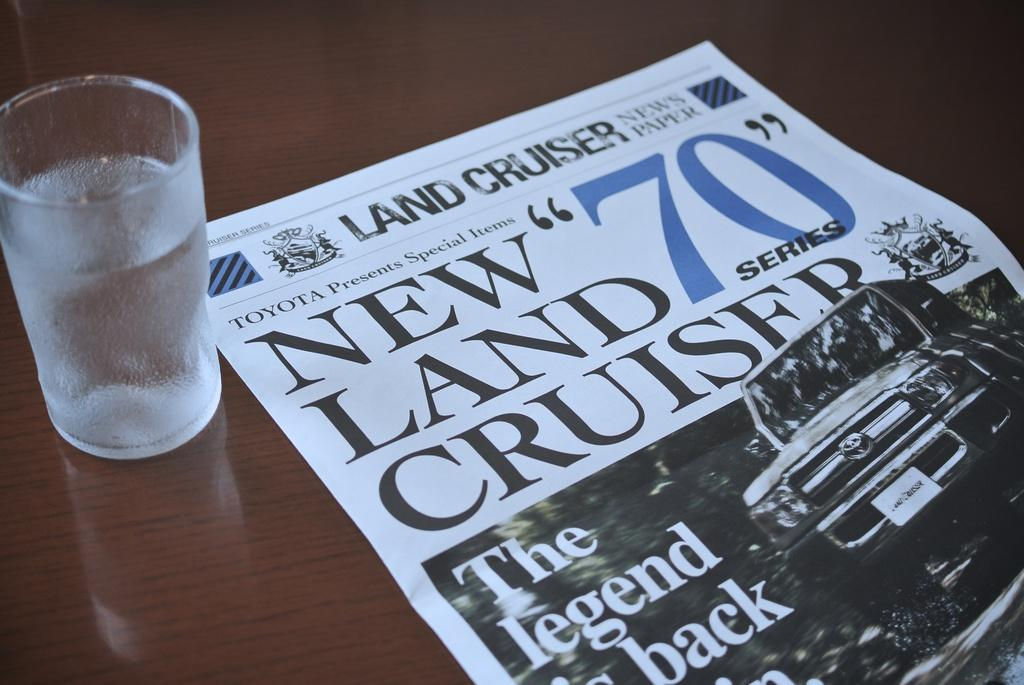Provide a one-sentence caption for the provided image. a water glass and newspaper that says NEW LAND CRUISERS.. 